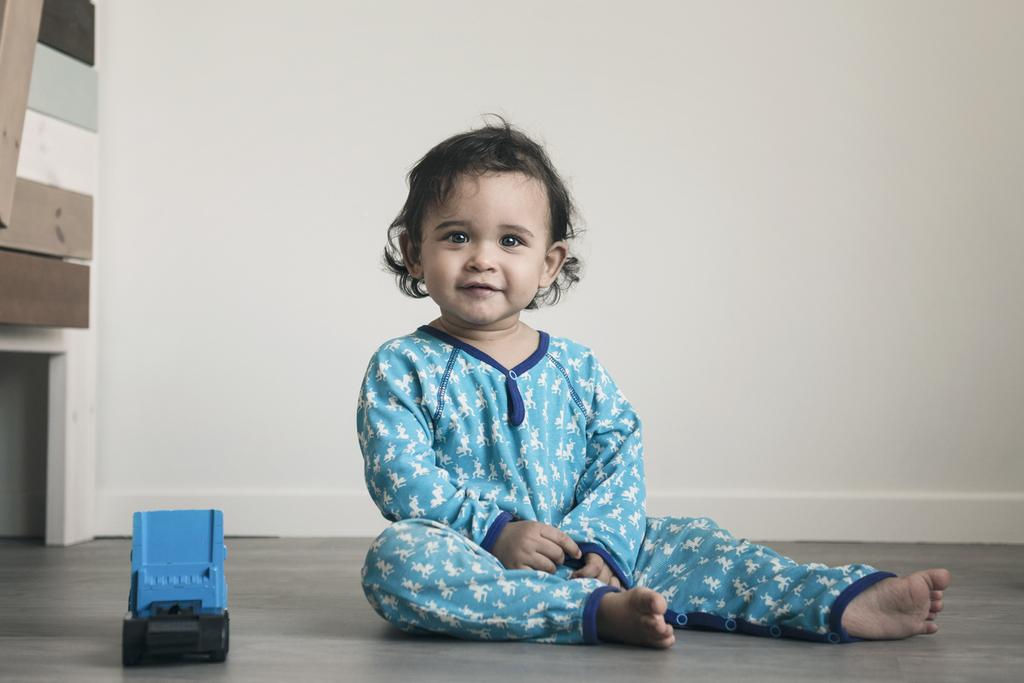What is the main subject of the image? The main subject of the image is a kid. Where is the kid located in the image? The kid is sitting on the floor. What can be seen on the left side of the kid? There is a toy on the left side of the kid. What is visible behind the kid? There is a wall behind the kid. What type of earthquake can be seen in the image? There is no earthquake present in the image; it features a kid sitting on the floor with a toy on the left side and a wall behind them. What is the kid using to collect water in the image? There is no basin or water collection activity present in the image. 